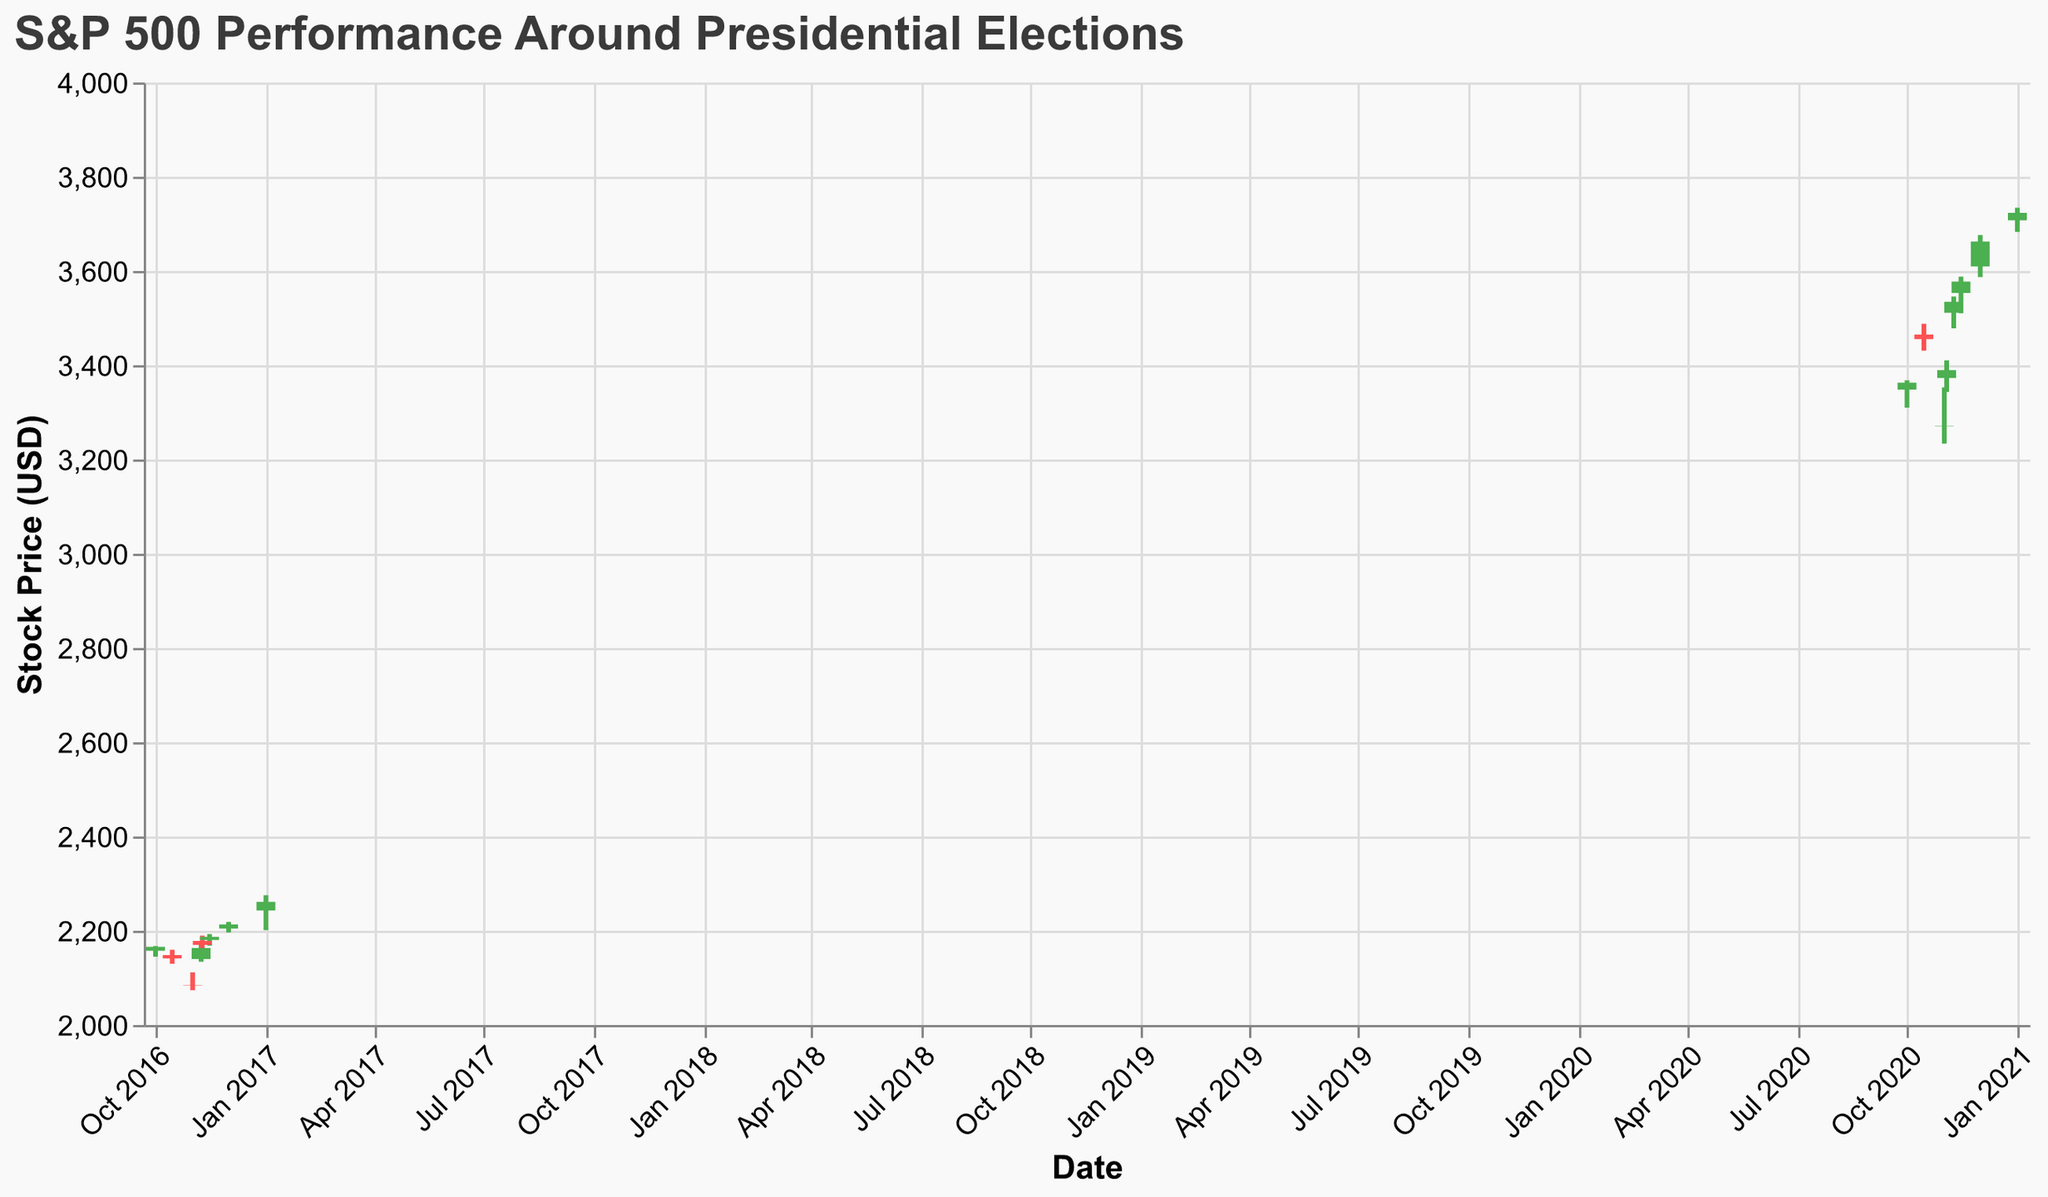What is the title of the figure? The title is at the top of the figure, it is "S&P 500 Performance Around Presidential Elections."
Answer: "S&P 500 Performance Around Presidential Elections" What are the date ranges shown in the figure? The date range can be found on the x-axis, spanning from "Oct 2016" to "Jan 2021."
Answer: "Oct 2016" to "Jan 2021" How is the color used to differentiate stock price changes? The figure uses green for days when the closing price is higher than the opening price and red for days when the closing price is lower than the opening price.
Answer: Green for increase, Red for decrease What is the S&P 500 closing price on the day of the 2016 election (Nov 8, 2016)? Find the date "Nov 8, 2016" on the x-axis and check the corresponding price bar. The closing price is given by the higher end of the bar, which is 2163.26.
Answer: 2163.26 Compare the closing prices on Nov 8, 2016, and Nov 9, 2016. Which day had a higher closing price? Identify the dates Nov 8, 2016, and Nov 9, 2016 on the x-axis. The figure shows closing prices of 2163.26 on Nov 8 and 2169.93 on Nov 9. Hence, Nov 9 had a higher closing price.
Answer: Nov 9, 2016 What is the average closing price in October 2020? Find the closing prices in October 2020 which are on dates "Oct 1" and "Oct 15". Add these prices: 3363.00 + 3455.25 and divide by 2. (3363.00 + 3455.25) / 2 = 3409.125
Answer: 3409.125 How did the S&P 500 perform immediately after the 2020 election? The 2020 election was on Nov 3. Identify and compare the closing prices from Nov 3 to Nov 9; prices rose steadily: 3389.78 on Nov 3 and 3534.48 on Nov 9.
Answer: It increased Between January 2017 and January 2021, did the S&P 500 generally increase or decrease? Start from the closing price in January 2017 (2261.26) and compare it to the closing price in January 2021 (3723.27). It shows an overall increase.
Answer: Increase What was the trading volume on Nov 9, 2016, compared to Nov 9, 2020? Check the volume data on the y-axis to the right. Nov 9, 2016, had a volume of 3100000000, whereas Nov 9, 2020, had a volume of 3200000000.
Answer: Higher in 2020 On which date between October 2016 and January 2017 did the S&P 500 have the highest closing price? Scan the closing prices between October 2016 and January 2017, with the highest value being on Jan 1, 2017 (2261.26).
Answer: Jan 1, 2017 